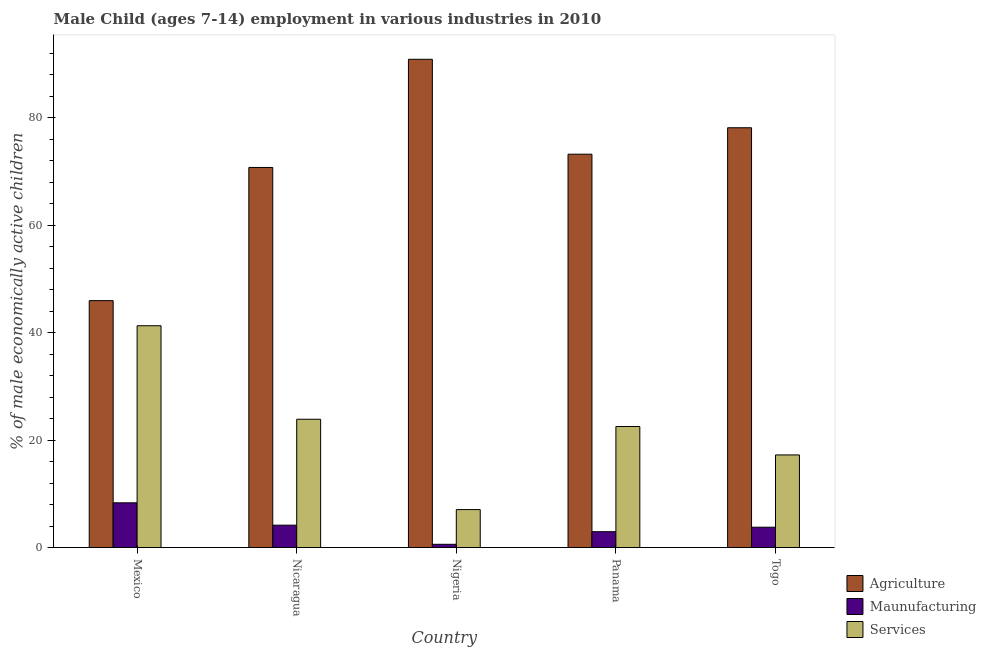How many groups of bars are there?
Your answer should be compact. 5. What is the label of the 5th group of bars from the left?
Offer a terse response. Togo. In how many cases, is the number of bars for a given country not equal to the number of legend labels?
Provide a succinct answer. 0. What is the percentage of economically active children in agriculture in Mexico?
Your answer should be compact. 45.94. Across all countries, what is the maximum percentage of economically active children in agriculture?
Offer a terse response. 90.85. Across all countries, what is the minimum percentage of economically active children in services?
Offer a terse response. 7.06. In which country was the percentage of economically active children in agriculture maximum?
Offer a very short reply. Nigeria. In which country was the percentage of economically active children in manufacturing minimum?
Provide a short and direct response. Nigeria. What is the total percentage of economically active children in agriculture in the graph?
Ensure brevity in your answer.  358.81. What is the difference between the percentage of economically active children in agriculture in Mexico and that in Panama?
Ensure brevity in your answer.  -27.25. What is the difference between the percentage of economically active children in agriculture in Togo and the percentage of economically active children in manufacturing in Panama?
Offer a very short reply. 75.16. What is the average percentage of economically active children in manufacturing per country?
Your answer should be compact. 3.96. What is the difference between the percentage of economically active children in agriculture and percentage of economically active children in manufacturing in Panama?
Offer a very short reply. 70.24. What is the ratio of the percentage of economically active children in agriculture in Nicaragua to that in Panama?
Offer a very short reply. 0.97. Is the percentage of economically active children in manufacturing in Nigeria less than that in Togo?
Your answer should be compact. Yes. Is the difference between the percentage of economically active children in manufacturing in Nigeria and Panama greater than the difference between the percentage of economically active children in services in Nigeria and Panama?
Ensure brevity in your answer.  Yes. What is the difference between the highest and the second highest percentage of economically active children in services?
Provide a succinct answer. 17.4. What is the difference between the highest and the lowest percentage of economically active children in services?
Offer a terse response. 34.21. Is the sum of the percentage of economically active children in manufacturing in Mexico and Nigeria greater than the maximum percentage of economically active children in agriculture across all countries?
Offer a terse response. No. What does the 3rd bar from the left in Mexico represents?
Provide a short and direct response. Services. What does the 1st bar from the right in Nigeria represents?
Make the answer very short. Services. Is it the case that in every country, the sum of the percentage of economically active children in agriculture and percentage of economically active children in manufacturing is greater than the percentage of economically active children in services?
Make the answer very short. Yes. How many bars are there?
Your response must be concise. 15. Are all the bars in the graph horizontal?
Give a very brief answer. No. Does the graph contain grids?
Give a very brief answer. No. How many legend labels are there?
Provide a succinct answer. 3. What is the title of the graph?
Provide a short and direct response. Male Child (ages 7-14) employment in various industries in 2010. What is the label or title of the X-axis?
Provide a short and direct response. Country. What is the label or title of the Y-axis?
Provide a succinct answer. % of male economically active children. What is the % of male economically active children in Agriculture in Mexico?
Provide a succinct answer. 45.94. What is the % of male economically active children of Maunufacturing in Mexico?
Provide a succinct answer. 8.32. What is the % of male economically active children in Services in Mexico?
Give a very brief answer. 41.27. What is the % of male economically active children in Agriculture in Nicaragua?
Make the answer very short. 70.72. What is the % of male economically active children of Maunufacturing in Nicaragua?
Give a very brief answer. 4.16. What is the % of male economically active children of Services in Nicaragua?
Give a very brief answer. 23.87. What is the % of male economically active children of Agriculture in Nigeria?
Provide a short and direct response. 90.85. What is the % of male economically active children of Services in Nigeria?
Offer a very short reply. 7.06. What is the % of male economically active children in Agriculture in Panama?
Keep it short and to the point. 73.19. What is the % of male economically active children of Maunufacturing in Panama?
Provide a short and direct response. 2.95. What is the % of male economically active children of Services in Panama?
Keep it short and to the point. 22.52. What is the % of male economically active children in Agriculture in Togo?
Provide a short and direct response. 78.11. What is the % of male economically active children of Maunufacturing in Togo?
Offer a terse response. 3.78. What is the % of male economically active children of Services in Togo?
Keep it short and to the point. 17.23. Across all countries, what is the maximum % of male economically active children in Agriculture?
Keep it short and to the point. 90.85. Across all countries, what is the maximum % of male economically active children of Maunufacturing?
Keep it short and to the point. 8.32. Across all countries, what is the maximum % of male economically active children in Services?
Ensure brevity in your answer.  41.27. Across all countries, what is the minimum % of male economically active children of Agriculture?
Ensure brevity in your answer.  45.94. Across all countries, what is the minimum % of male economically active children of Maunufacturing?
Your answer should be compact. 0.6. Across all countries, what is the minimum % of male economically active children of Services?
Your response must be concise. 7.06. What is the total % of male economically active children of Agriculture in the graph?
Your response must be concise. 358.81. What is the total % of male economically active children in Maunufacturing in the graph?
Give a very brief answer. 19.81. What is the total % of male economically active children of Services in the graph?
Your answer should be very brief. 111.95. What is the difference between the % of male economically active children of Agriculture in Mexico and that in Nicaragua?
Offer a terse response. -24.78. What is the difference between the % of male economically active children of Maunufacturing in Mexico and that in Nicaragua?
Your answer should be very brief. 4.16. What is the difference between the % of male economically active children in Services in Mexico and that in Nicaragua?
Your response must be concise. 17.4. What is the difference between the % of male economically active children of Agriculture in Mexico and that in Nigeria?
Ensure brevity in your answer.  -44.91. What is the difference between the % of male economically active children of Maunufacturing in Mexico and that in Nigeria?
Ensure brevity in your answer.  7.72. What is the difference between the % of male economically active children of Services in Mexico and that in Nigeria?
Make the answer very short. 34.21. What is the difference between the % of male economically active children of Agriculture in Mexico and that in Panama?
Your answer should be compact. -27.25. What is the difference between the % of male economically active children of Maunufacturing in Mexico and that in Panama?
Keep it short and to the point. 5.37. What is the difference between the % of male economically active children of Services in Mexico and that in Panama?
Your answer should be compact. 18.75. What is the difference between the % of male economically active children of Agriculture in Mexico and that in Togo?
Offer a terse response. -32.17. What is the difference between the % of male economically active children in Maunufacturing in Mexico and that in Togo?
Keep it short and to the point. 4.54. What is the difference between the % of male economically active children in Services in Mexico and that in Togo?
Give a very brief answer. 24.04. What is the difference between the % of male economically active children in Agriculture in Nicaragua and that in Nigeria?
Provide a short and direct response. -20.13. What is the difference between the % of male economically active children in Maunufacturing in Nicaragua and that in Nigeria?
Provide a short and direct response. 3.56. What is the difference between the % of male economically active children of Services in Nicaragua and that in Nigeria?
Keep it short and to the point. 16.81. What is the difference between the % of male economically active children in Agriculture in Nicaragua and that in Panama?
Give a very brief answer. -2.47. What is the difference between the % of male economically active children in Maunufacturing in Nicaragua and that in Panama?
Offer a terse response. 1.21. What is the difference between the % of male economically active children in Services in Nicaragua and that in Panama?
Give a very brief answer. 1.35. What is the difference between the % of male economically active children in Agriculture in Nicaragua and that in Togo?
Offer a terse response. -7.39. What is the difference between the % of male economically active children of Maunufacturing in Nicaragua and that in Togo?
Make the answer very short. 0.38. What is the difference between the % of male economically active children in Services in Nicaragua and that in Togo?
Provide a succinct answer. 6.64. What is the difference between the % of male economically active children of Agriculture in Nigeria and that in Panama?
Your response must be concise. 17.66. What is the difference between the % of male economically active children of Maunufacturing in Nigeria and that in Panama?
Offer a very short reply. -2.35. What is the difference between the % of male economically active children of Services in Nigeria and that in Panama?
Keep it short and to the point. -15.46. What is the difference between the % of male economically active children in Agriculture in Nigeria and that in Togo?
Offer a terse response. 12.74. What is the difference between the % of male economically active children in Maunufacturing in Nigeria and that in Togo?
Provide a short and direct response. -3.18. What is the difference between the % of male economically active children of Services in Nigeria and that in Togo?
Your response must be concise. -10.17. What is the difference between the % of male economically active children in Agriculture in Panama and that in Togo?
Your answer should be compact. -4.92. What is the difference between the % of male economically active children in Maunufacturing in Panama and that in Togo?
Keep it short and to the point. -0.83. What is the difference between the % of male economically active children of Services in Panama and that in Togo?
Your response must be concise. 5.29. What is the difference between the % of male economically active children in Agriculture in Mexico and the % of male economically active children in Maunufacturing in Nicaragua?
Offer a terse response. 41.78. What is the difference between the % of male economically active children of Agriculture in Mexico and the % of male economically active children of Services in Nicaragua?
Offer a terse response. 22.07. What is the difference between the % of male economically active children of Maunufacturing in Mexico and the % of male economically active children of Services in Nicaragua?
Your answer should be compact. -15.55. What is the difference between the % of male economically active children in Agriculture in Mexico and the % of male economically active children in Maunufacturing in Nigeria?
Your answer should be compact. 45.34. What is the difference between the % of male economically active children in Agriculture in Mexico and the % of male economically active children in Services in Nigeria?
Offer a terse response. 38.88. What is the difference between the % of male economically active children of Maunufacturing in Mexico and the % of male economically active children of Services in Nigeria?
Your answer should be compact. 1.26. What is the difference between the % of male economically active children of Agriculture in Mexico and the % of male economically active children of Maunufacturing in Panama?
Provide a succinct answer. 42.99. What is the difference between the % of male economically active children of Agriculture in Mexico and the % of male economically active children of Services in Panama?
Your answer should be compact. 23.42. What is the difference between the % of male economically active children of Maunufacturing in Mexico and the % of male economically active children of Services in Panama?
Offer a terse response. -14.2. What is the difference between the % of male economically active children of Agriculture in Mexico and the % of male economically active children of Maunufacturing in Togo?
Offer a terse response. 42.16. What is the difference between the % of male economically active children of Agriculture in Mexico and the % of male economically active children of Services in Togo?
Your answer should be very brief. 28.71. What is the difference between the % of male economically active children in Maunufacturing in Mexico and the % of male economically active children in Services in Togo?
Keep it short and to the point. -8.91. What is the difference between the % of male economically active children in Agriculture in Nicaragua and the % of male economically active children in Maunufacturing in Nigeria?
Keep it short and to the point. 70.12. What is the difference between the % of male economically active children in Agriculture in Nicaragua and the % of male economically active children in Services in Nigeria?
Your response must be concise. 63.66. What is the difference between the % of male economically active children in Maunufacturing in Nicaragua and the % of male economically active children in Services in Nigeria?
Provide a short and direct response. -2.9. What is the difference between the % of male economically active children in Agriculture in Nicaragua and the % of male economically active children in Maunufacturing in Panama?
Offer a terse response. 67.77. What is the difference between the % of male economically active children in Agriculture in Nicaragua and the % of male economically active children in Services in Panama?
Keep it short and to the point. 48.2. What is the difference between the % of male economically active children in Maunufacturing in Nicaragua and the % of male economically active children in Services in Panama?
Your answer should be compact. -18.36. What is the difference between the % of male economically active children of Agriculture in Nicaragua and the % of male economically active children of Maunufacturing in Togo?
Provide a short and direct response. 66.94. What is the difference between the % of male economically active children of Agriculture in Nicaragua and the % of male economically active children of Services in Togo?
Keep it short and to the point. 53.49. What is the difference between the % of male economically active children of Maunufacturing in Nicaragua and the % of male economically active children of Services in Togo?
Your answer should be compact. -13.07. What is the difference between the % of male economically active children of Agriculture in Nigeria and the % of male economically active children of Maunufacturing in Panama?
Offer a terse response. 87.9. What is the difference between the % of male economically active children in Agriculture in Nigeria and the % of male economically active children in Services in Panama?
Offer a very short reply. 68.33. What is the difference between the % of male economically active children in Maunufacturing in Nigeria and the % of male economically active children in Services in Panama?
Provide a succinct answer. -21.92. What is the difference between the % of male economically active children of Agriculture in Nigeria and the % of male economically active children of Maunufacturing in Togo?
Make the answer very short. 87.07. What is the difference between the % of male economically active children of Agriculture in Nigeria and the % of male economically active children of Services in Togo?
Your response must be concise. 73.62. What is the difference between the % of male economically active children of Maunufacturing in Nigeria and the % of male economically active children of Services in Togo?
Your answer should be very brief. -16.63. What is the difference between the % of male economically active children of Agriculture in Panama and the % of male economically active children of Maunufacturing in Togo?
Make the answer very short. 69.41. What is the difference between the % of male economically active children in Agriculture in Panama and the % of male economically active children in Services in Togo?
Your answer should be compact. 55.96. What is the difference between the % of male economically active children of Maunufacturing in Panama and the % of male economically active children of Services in Togo?
Offer a very short reply. -14.28. What is the average % of male economically active children of Agriculture per country?
Offer a very short reply. 71.76. What is the average % of male economically active children in Maunufacturing per country?
Your response must be concise. 3.96. What is the average % of male economically active children of Services per country?
Make the answer very short. 22.39. What is the difference between the % of male economically active children in Agriculture and % of male economically active children in Maunufacturing in Mexico?
Your answer should be compact. 37.62. What is the difference between the % of male economically active children of Agriculture and % of male economically active children of Services in Mexico?
Make the answer very short. 4.67. What is the difference between the % of male economically active children in Maunufacturing and % of male economically active children in Services in Mexico?
Your answer should be compact. -32.95. What is the difference between the % of male economically active children of Agriculture and % of male economically active children of Maunufacturing in Nicaragua?
Offer a terse response. 66.56. What is the difference between the % of male economically active children of Agriculture and % of male economically active children of Services in Nicaragua?
Your answer should be very brief. 46.85. What is the difference between the % of male economically active children in Maunufacturing and % of male economically active children in Services in Nicaragua?
Offer a very short reply. -19.71. What is the difference between the % of male economically active children in Agriculture and % of male economically active children in Maunufacturing in Nigeria?
Give a very brief answer. 90.25. What is the difference between the % of male economically active children of Agriculture and % of male economically active children of Services in Nigeria?
Your answer should be compact. 83.79. What is the difference between the % of male economically active children of Maunufacturing and % of male economically active children of Services in Nigeria?
Your answer should be very brief. -6.46. What is the difference between the % of male economically active children of Agriculture and % of male economically active children of Maunufacturing in Panama?
Make the answer very short. 70.24. What is the difference between the % of male economically active children in Agriculture and % of male economically active children in Services in Panama?
Keep it short and to the point. 50.67. What is the difference between the % of male economically active children in Maunufacturing and % of male economically active children in Services in Panama?
Ensure brevity in your answer.  -19.57. What is the difference between the % of male economically active children in Agriculture and % of male economically active children in Maunufacturing in Togo?
Your response must be concise. 74.33. What is the difference between the % of male economically active children in Agriculture and % of male economically active children in Services in Togo?
Your response must be concise. 60.88. What is the difference between the % of male economically active children of Maunufacturing and % of male economically active children of Services in Togo?
Keep it short and to the point. -13.45. What is the ratio of the % of male economically active children in Agriculture in Mexico to that in Nicaragua?
Provide a short and direct response. 0.65. What is the ratio of the % of male economically active children of Maunufacturing in Mexico to that in Nicaragua?
Give a very brief answer. 2. What is the ratio of the % of male economically active children in Services in Mexico to that in Nicaragua?
Offer a terse response. 1.73. What is the ratio of the % of male economically active children of Agriculture in Mexico to that in Nigeria?
Offer a terse response. 0.51. What is the ratio of the % of male economically active children of Maunufacturing in Mexico to that in Nigeria?
Provide a short and direct response. 13.87. What is the ratio of the % of male economically active children in Services in Mexico to that in Nigeria?
Make the answer very short. 5.85. What is the ratio of the % of male economically active children of Agriculture in Mexico to that in Panama?
Ensure brevity in your answer.  0.63. What is the ratio of the % of male economically active children in Maunufacturing in Mexico to that in Panama?
Provide a short and direct response. 2.82. What is the ratio of the % of male economically active children in Services in Mexico to that in Panama?
Ensure brevity in your answer.  1.83. What is the ratio of the % of male economically active children of Agriculture in Mexico to that in Togo?
Provide a succinct answer. 0.59. What is the ratio of the % of male economically active children in Maunufacturing in Mexico to that in Togo?
Offer a terse response. 2.2. What is the ratio of the % of male economically active children of Services in Mexico to that in Togo?
Offer a very short reply. 2.4. What is the ratio of the % of male economically active children of Agriculture in Nicaragua to that in Nigeria?
Provide a short and direct response. 0.78. What is the ratio of the % of male economically active children of Maunufacturing in Nicaragua to that in Nigeria?
Provide a succinct answer. 6.93. What is the ratio of the % of male economically active children of Services in Nicaragua to that in Nigeria?
Offer a very short reply. 3.38. What is the ratio of the % of male economically active children of Agriculture in Nicaragua to that in Panama?
Keep it short and to the point. 0.97. What is the ratio of the % of male economically active children of Maunufacturing in Nicaragua to that in Panama?
Your answer should be very brief. 1.41. What is the ratio of the % of male economically active children in Services in Nicaragua to that in Panama?
Your answer should be very brief. 1.06. What is the ratio of the % of male economically active children in Agriculture in Nicaragua to that in Togo?
Ensure brevity in your answer.  0.91. What is the ratio of the % of male economically active children in Maunufacturing in Nicaragua to that in Togo?
Your answer should be very brief. 1.1. What is the ratio of the % of male economically active children in Services in Nicaragua to that in Togo?
Give a very brief answer. 1.39. What is the ratio of the % of male economically active children in Agriculture in Nigeria to that in Panama?
Your answer should be very brief. 1.24. What is the ratio of the % of male economically active children in Maunufacturing in Nigeria to that in Panama?
Provide a short and direct response. 0.2. What is the ratio of the % of male economically active children of Services in Nigeria to that in Panama?
Ensure brevity in your answer.  0.31. What is the ratio of the % of male economically active children of Agriculture in Nigeria to that in Togo?
Provide a succinct answer. 1.16. What is the ratio of the % of male economically active children in Maunufacturing in Nigeria to that in Togo?
Give a very brief answer. 0.16. What is the ratio of the % of male economically active children of Services in Nigeria to that in Togo?
Keep it short and to the point. 0.41. What is the ratio of the % of male economically active children in Agriculture in Panama to that in Togo?
Provide a short and direct response. 0.94. What is the ratio of the % of male economically active children in Maunufacturing in Panama to that in Togo?
Keep it short and to the point. 0.78. What is the ratio of the % of male economically active children in Services in Panama to that in Togo?
Provide a succinct answer. 1.31. What is the difference between the highest and the second highest % of male economically active children of Agriculture?
Provide a succinct answer. 12.74. What is the difference between the highest and the second highest % of male economically active children in Maunufacturing?
Your response must be concise. 4.16. What is the difference between the highest and the second highest % of male economically active children of Services?
Your response must be concise. 17.4. What is the difference between the highest and the lowest % of male economically active children in Agriculture?
Keep it short and to the point. 44.91. What is the difference between the highest and the lowest % of male economically active children of Maunufacturing?
Your answer should be compact. 7.72. What is the difference between the highest and the lowest % of male economically active children in Services?
Offer a terse response. 34.21. 